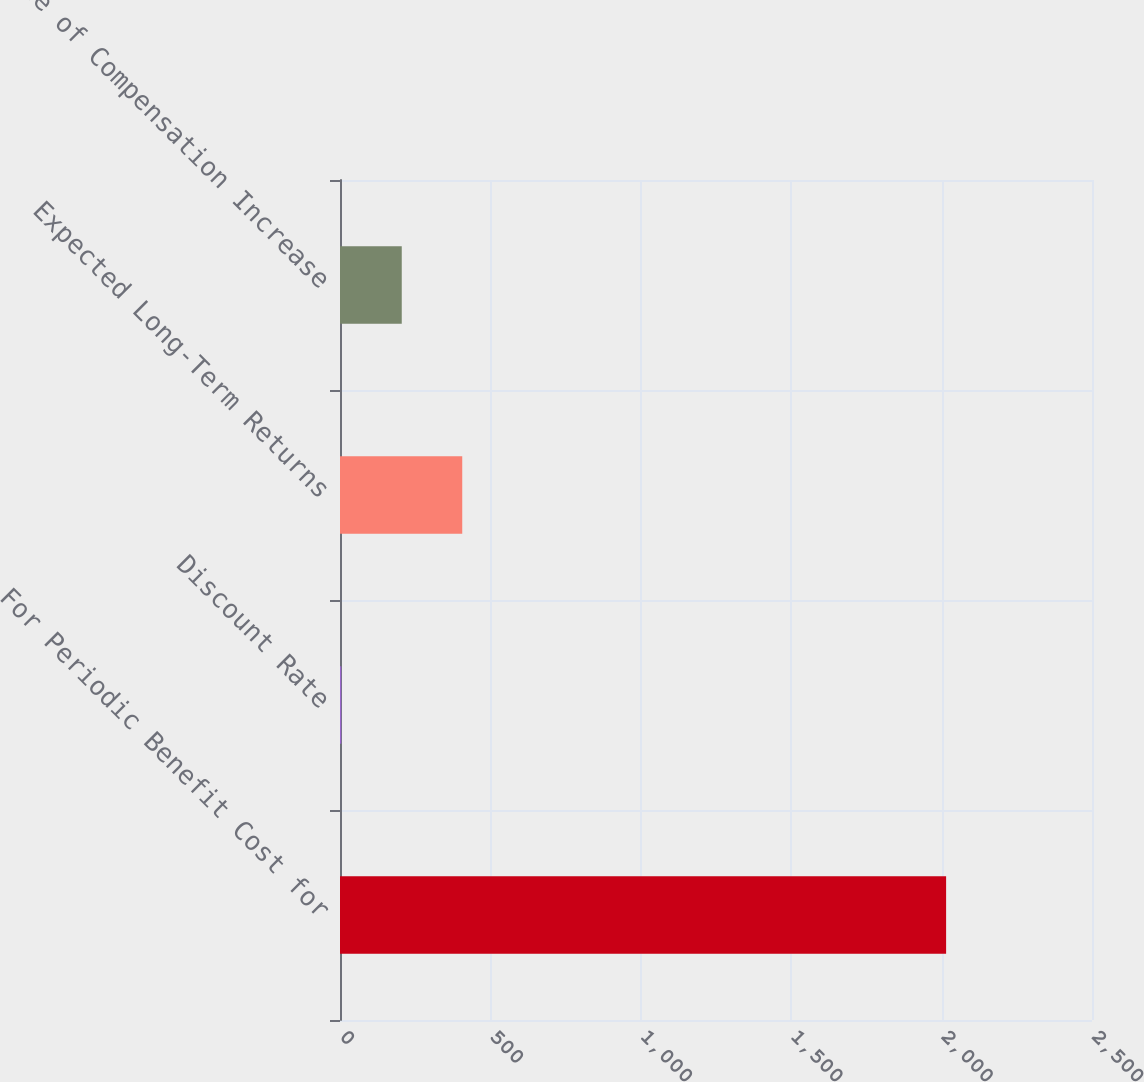<chart> <loc_0><loc_0><loc_500><loc_500><bar_chart><fcel>For Periodic Benefit Cost for<fcel>Discount Rate<fcel>Expected Long-Term Returns<fcel>Rate of Compensation Increase<nl><fcel>2015<fcel>4.23<fcel>406.39<fcel>205.31<nl></chart> 